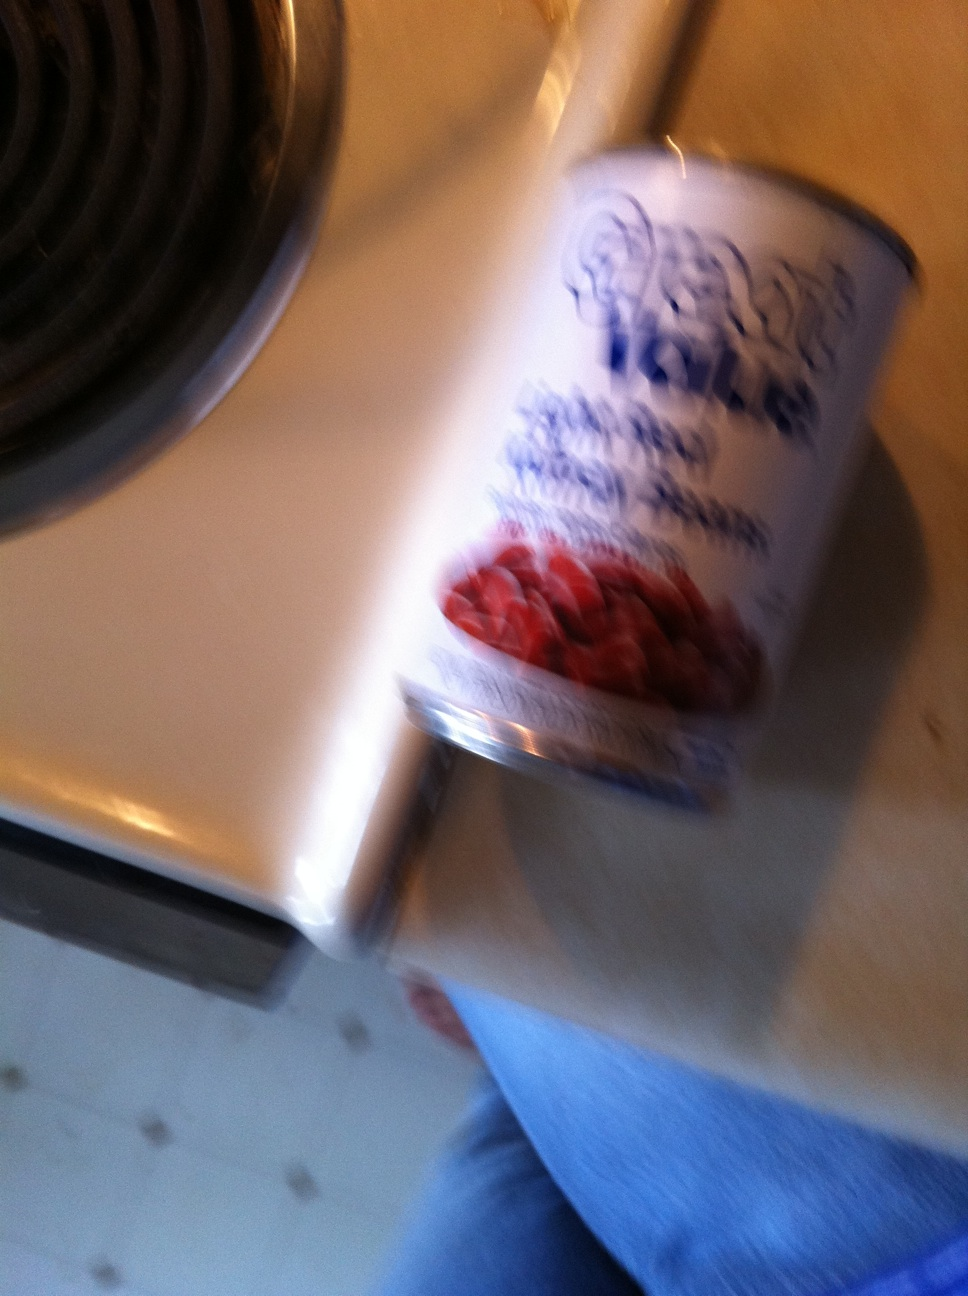Can you tell what variety of beans are in this can? Due to the blur in the image, it's challenging to specify the variety, but they seem to be a common type such as kidney beans or pinto beans, often used in home cooking. 